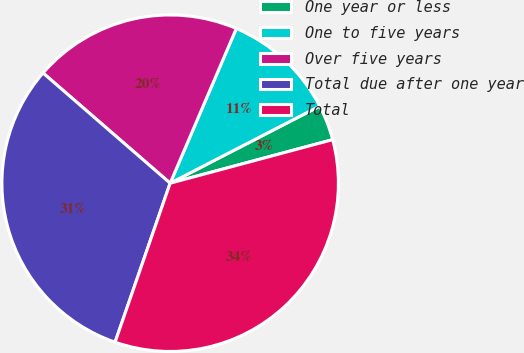Convert chart to OTSL. <chart><loc_0><loc_0><loc_500><loc_500><pie_chart><fcel>One year or less<fcel>One to five years<fcel>Over five years<fcel>Total due after one year<fcel>Total<nl><fcel>3.41%<fcel>10.99%<fcel>20.06%<fcel>31.06%<fcel>34.47%<nl></chart> 